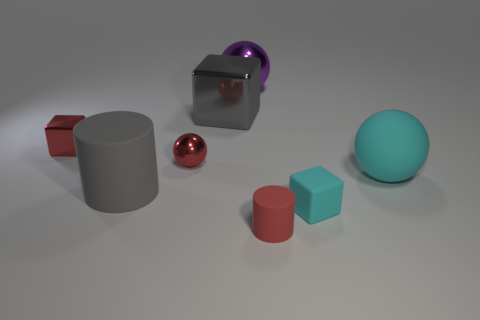Add 2 tiny gray rubber balls. How many objects exist? 10 Subtract all spheres. How many objects are left? 5 Add 5 large cylinders. How many large cylinders exist? 6 Subtract 0 blue spheres. How many objects are left? 8 Subtract all big red rubber cubes. Subtract all large gray things. How many objects are left? 6 Add 2 large metallic balls. How many large metallic balls are left? 3 